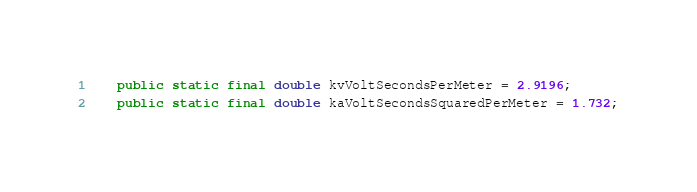<code> <loc_0><loc_0><loc_500><loc_500><_Java_>    public static final double kvVoltSecondsPerMeter = 2.9196;
    public static final double kaVoltSecondsSquaredPerMeter = 1.732;
</code> 